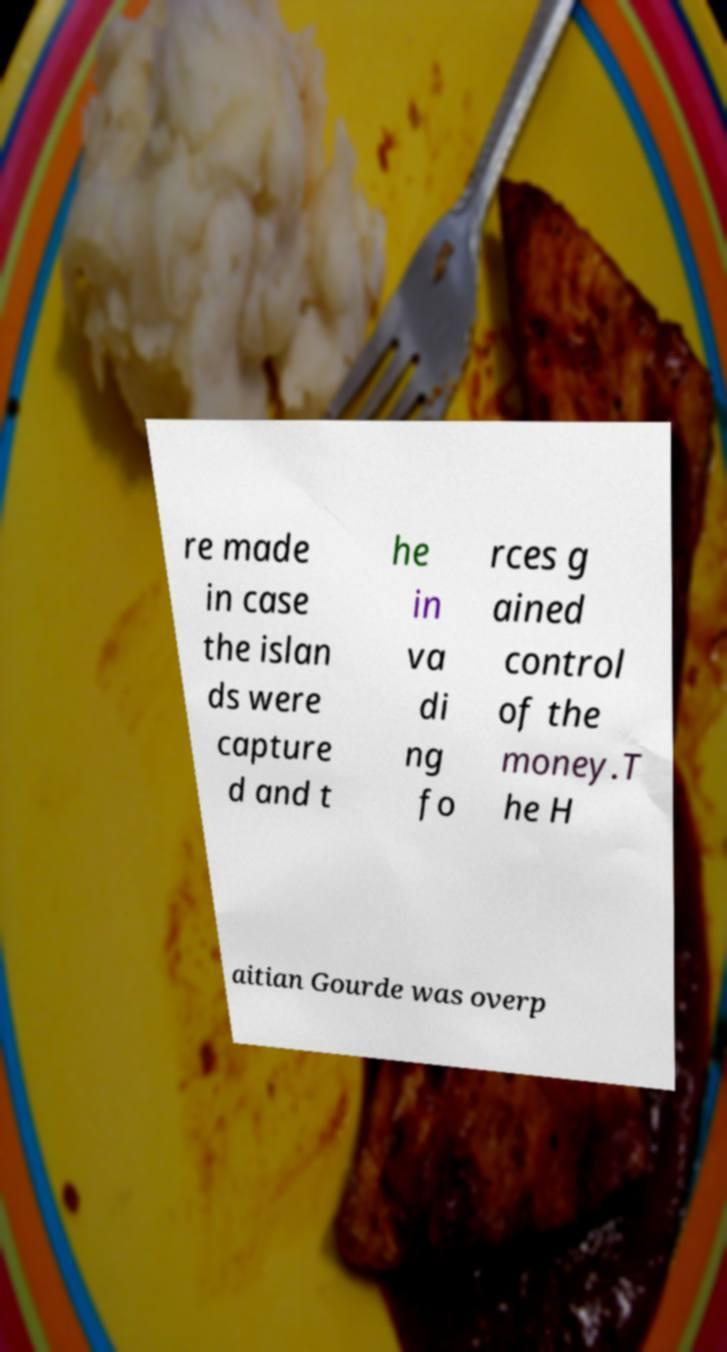Can you accurately transcribe the text from the provided image for me? re made in case the islan ds were capture d and t he in va di ng fo rces g ained control of the money.T he H aitian Gourde was overp 